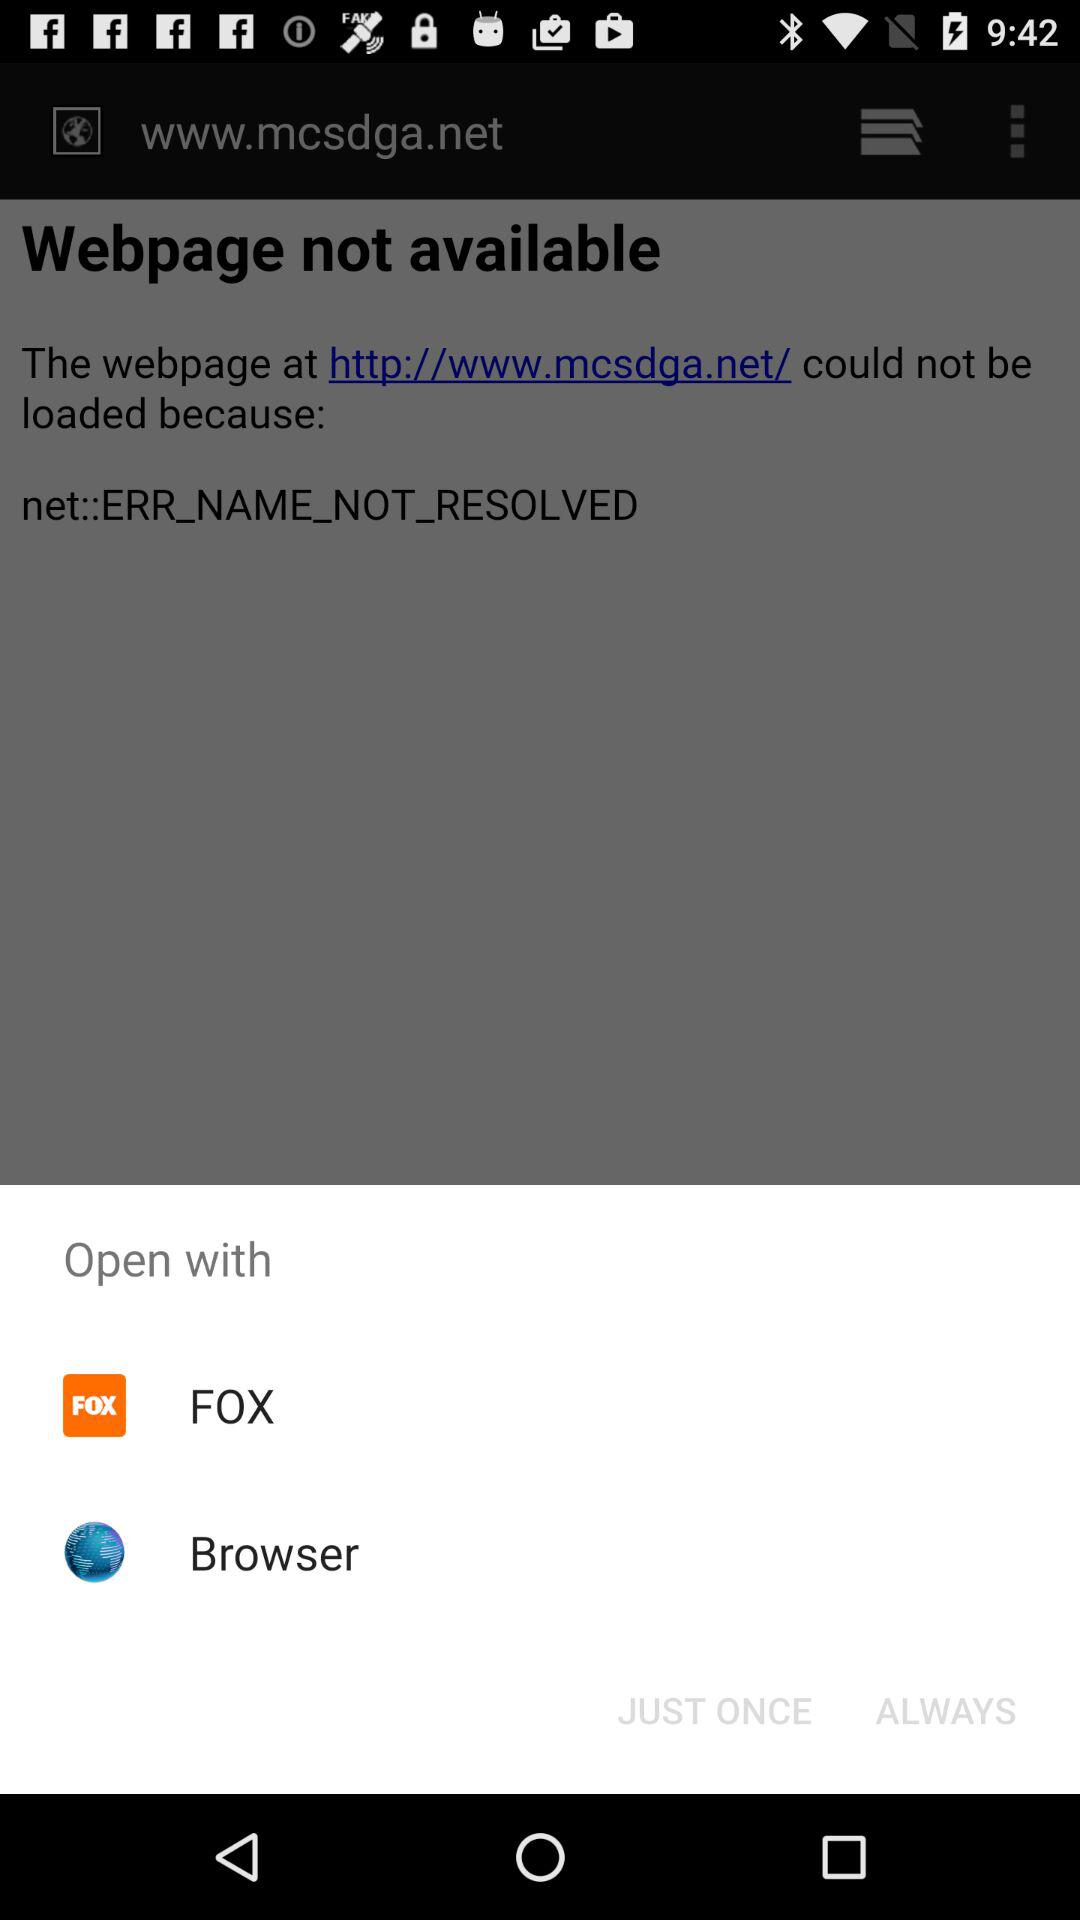What are the options to open with? The options to open with are "FOX" and "Browser". 